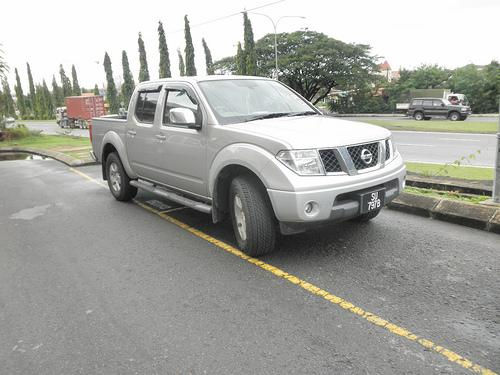What is the luxury division of this motor company? infinity 